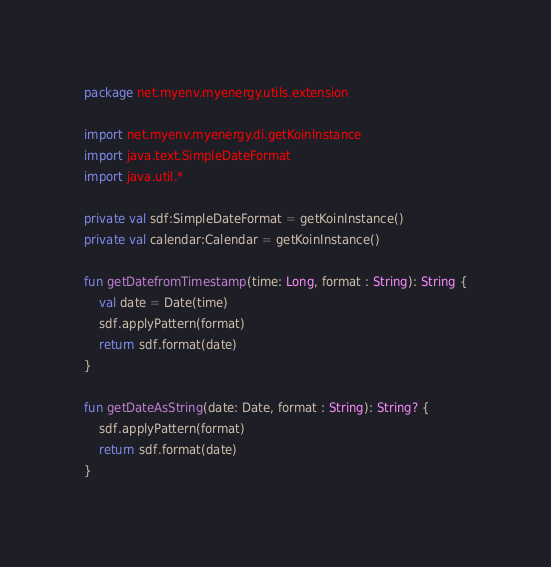Convert code to text. <code><loc_0><loc_0><loc_500><loc_500><_Kotlin_>package net.myenv.myenergy.utils.extension

import net.myenv.myenergy.di.getKoinInstance
import java.text.SimpleDateFormat
import java.util.*

private val sdf:SimpleDateFormat = getKoinInstance()
private val calendar:Calendar = getKoinInstance()

fun getDatefromTimestamp(time: Long, format : String): String {
    val date = Date(time)
    sdf.applyPattern(format)
    return sdf.format(date)
}

fun getDateAsString(date: Date, format : String): String? {
    sdf.applyPattern(format)
    return sdf.format(date)
}
</code> 